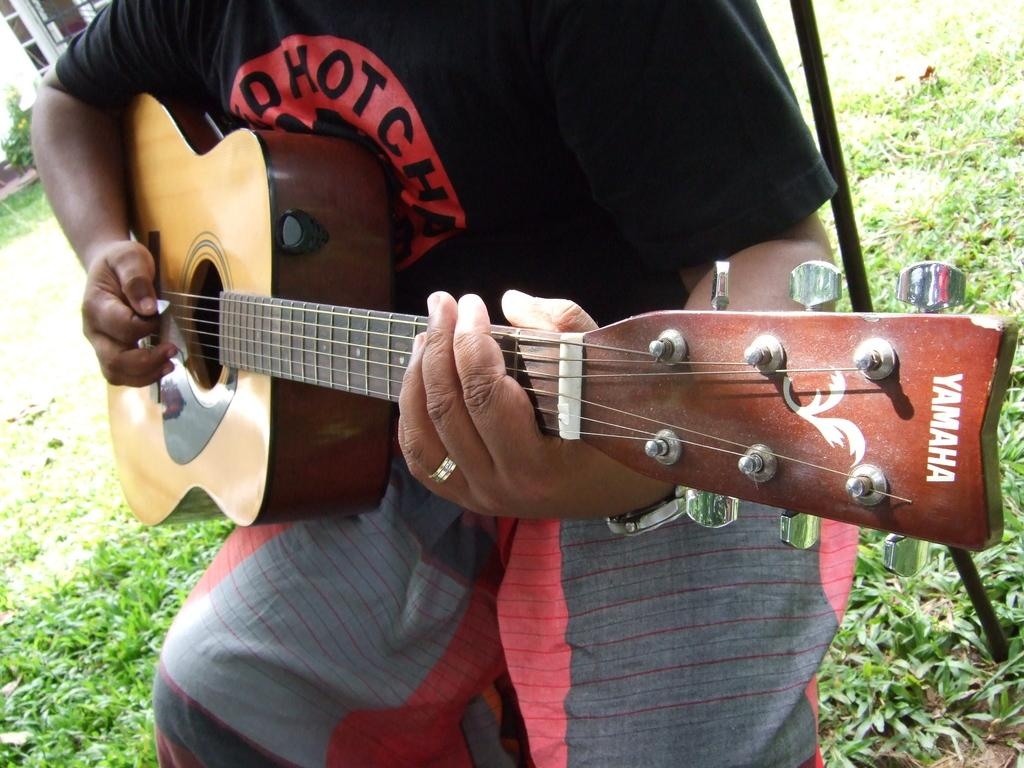Who is the person in the image? There is a man in the image. What is the man holding in the image? The man is holding a guitar. What is the man doing with the guitar? The man is playing the guitar. What type of surface is visible in the background of the image? There is grass on the floor in the background of the image. What structure can be seen in the background of the image? There is a building in the background of the image. Can you see any fish swimming in the seashore in the image? There is no seashore or fish present in the image; it features a man playing a guitar with a grassy background and a building in the distance. 